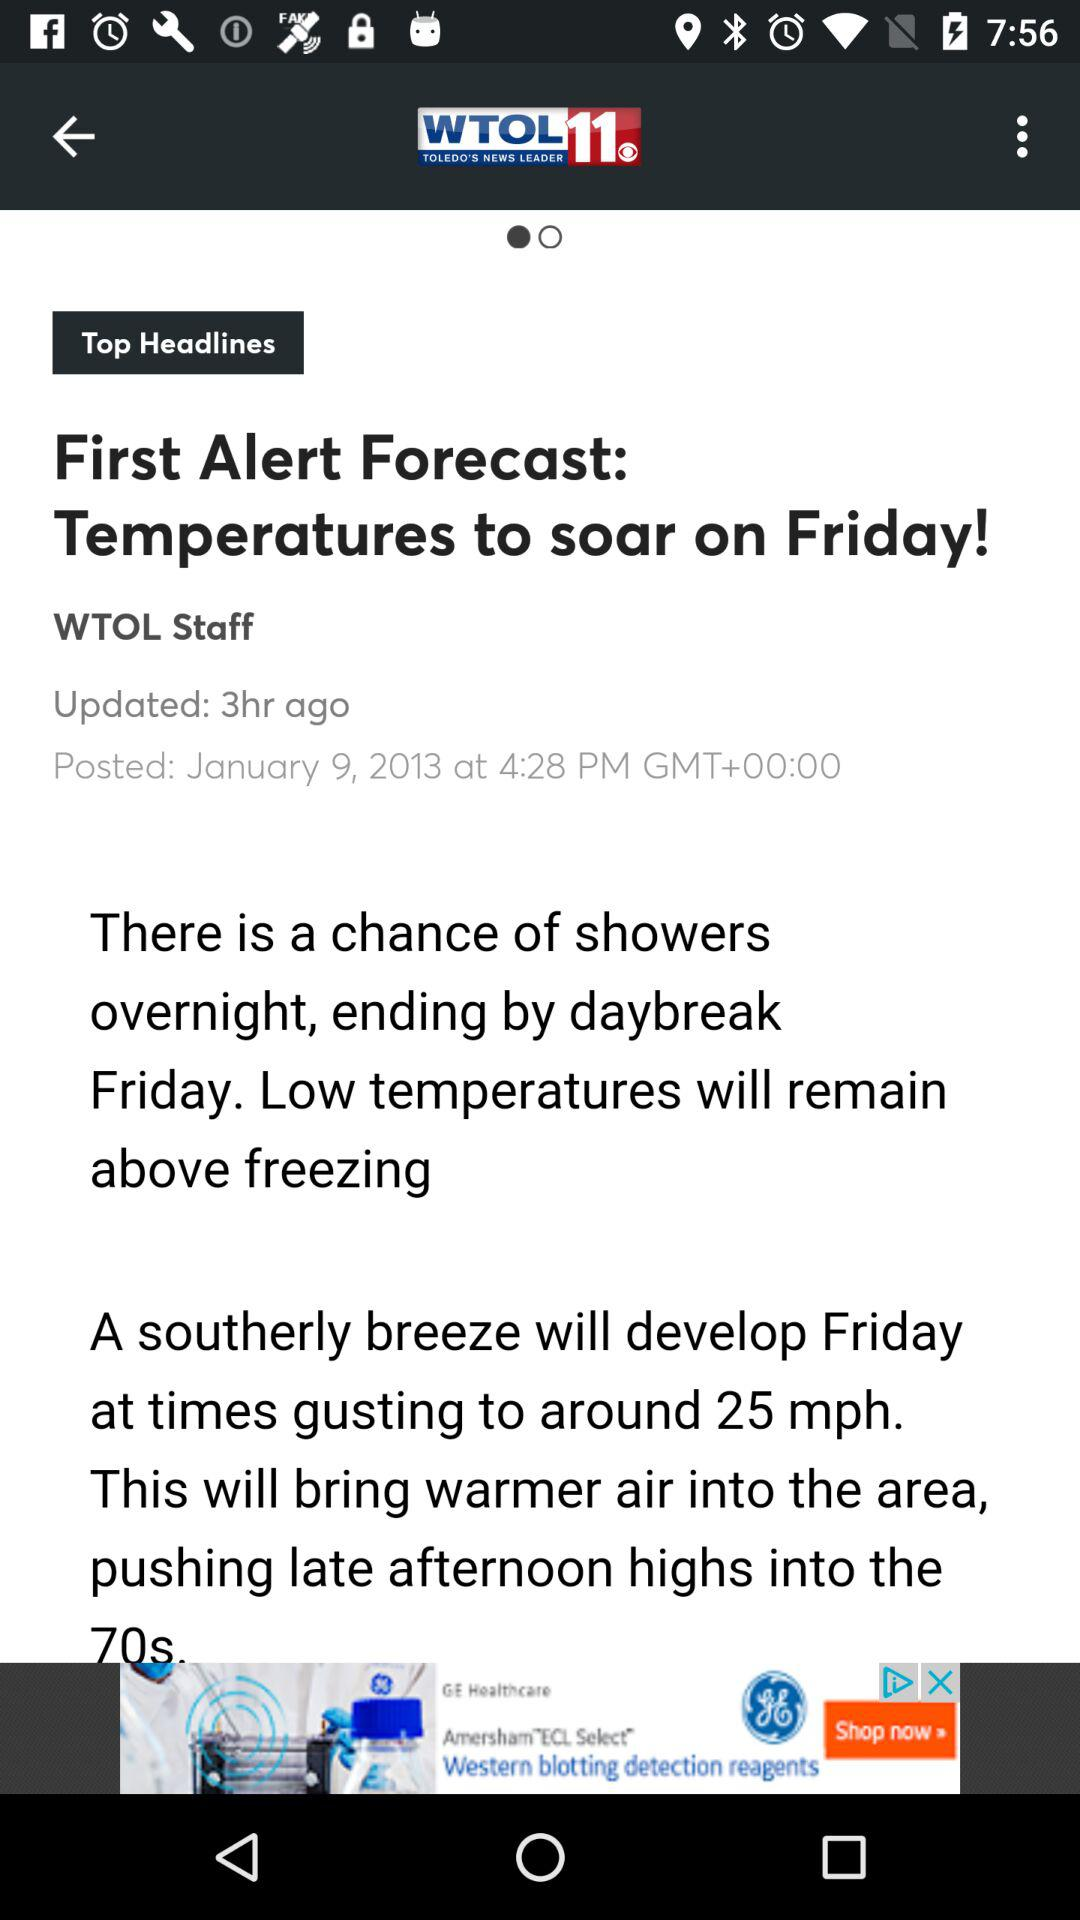When was the article updated? The article was updated 3 hours ago. 